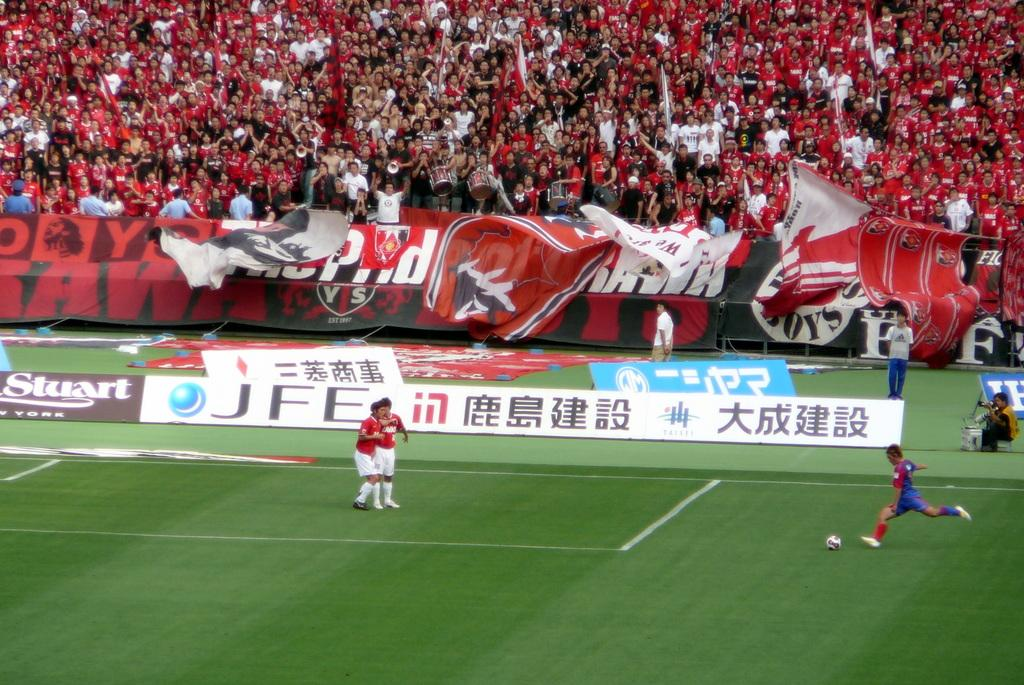<image>
Render a clear and concise summary of the photo. A soccer field with players playing a game in front of a stand full of fans with banners with Chinese writing in front of the stands. 